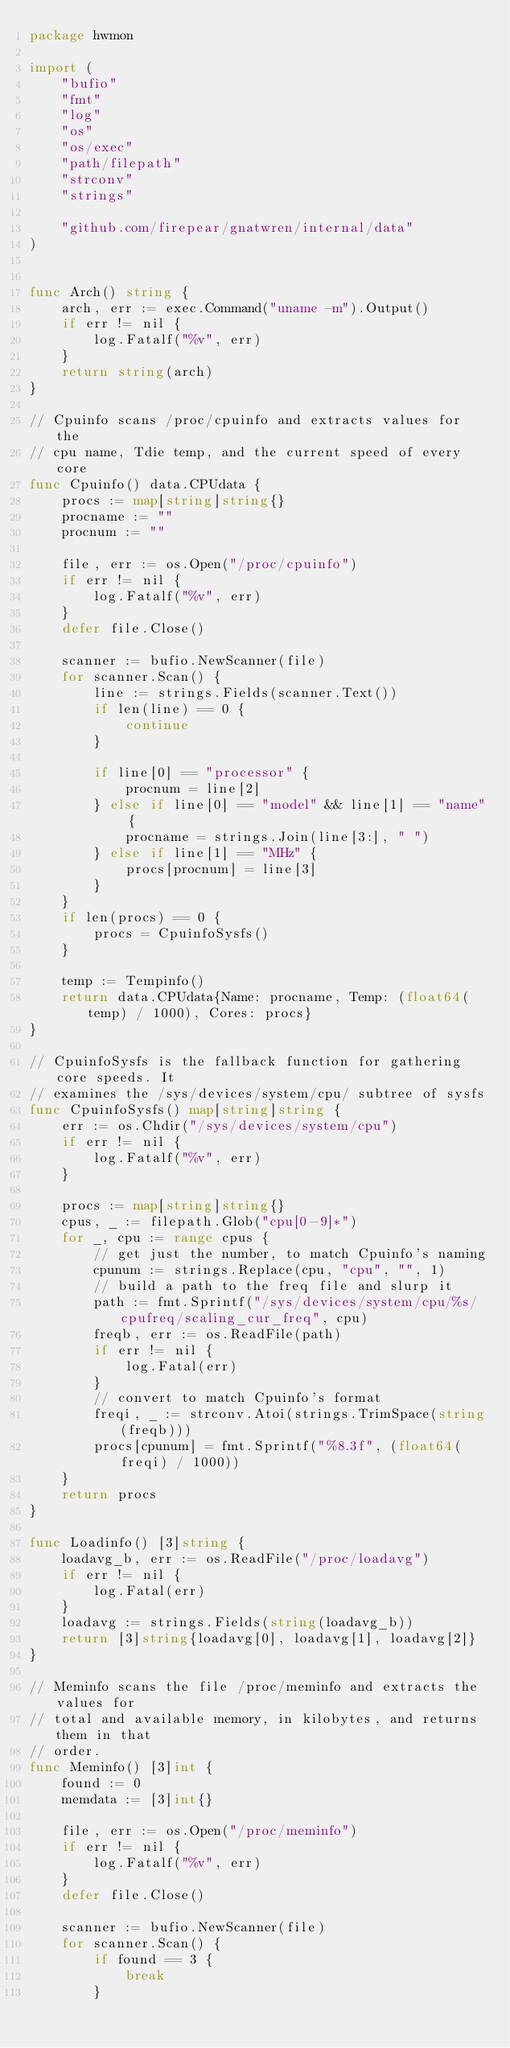Convert code to text. <code><loc_0><loc_0><loc_500><loc_500><_Go_>package hwmon

import (
	"bufio"
	"fmt"
	"log"
	"os"
	"os/exec"
	"path/filepath"
	"strconv"
	"strings"

	"github.com/firepear/gnatwren/internal/data"
)


func Arch() string {
	arch, err := exec.Command("uname -m").Output()
	if err != nil {
		log.Fatalf("%v", err)
	}
	return string(arch)
}

// Cpuinfo scans /proc/cpuinfo and extracts values for the
// cpu name, Tdie temp, and the current speed of every core
func Cpuinfo() data.CPUdata {
	procs := map[string]string{}
	procname := ""
	procnum := ""

	file, err := os.Open("/proc/cpuinfo")
	if err != nil {
		log.Fatalf("%v", err)
	}
	defer file.Close()

	scanner := bufio.NewScanner(file)
	for scanner.Scan() {
		line := strings.Fields(scanner.Text())
		if len(line) == 0 {
			continue
		}

		if line[0] == "processor" {
			procnum = line[2]
		} else if line[0] == "model" && line[1] == "name" {
			procname = strings.Join(line[3:], " ")
		} else if line[1] == "MHz" {
			procs[procnum] = line[3]
		}
	}
	if len(procs) == 0 {
		procs = CpuinfoSysfs()
	}

	temp := Tempinfo()
	return data.CPUdata{Name: procname, Temp: (float64(temp) / 1000), Cores: procs}
}

// CpuinfoSysfs is the fallback function for gathering core speeds. It
// examines the /sys/devices/system/cpu/ subtree of sysfs
func CpuinfoSysfs() map[string]string {
	err := os.Chdir("/sys/devices/system/cpu")
	if err != nil {
		log.Fatalf("%v", err)
	}

	procs := map[string]string{}
	cpus, _ := filepath.Glob("cpu[0-9]*")
	for _, cpu := range cpus {
		// get just the number, to match Cpuinfo's naming
		cpunum := strings.Replace(cpu, "cpu", "", 1)
		// build a path to the freq file and slurp it
		path := fmt.Sprintf("/sys/devices/system/cpu/%s/cpufreq/scaling_cur_freq", cpu)
		freqb, err := os.ReadFile(path)
		if err != nil {
			log.Fatal(err)
		}
		// convert to match Cpuinfo's format
		freqi, _ := strconv.Atoi(strings.TrimSpace(string(freqb)))
		procs[cpunum] = fmt.Sprintf("%8.3f", (float64(freqi) / 1000))
	}
	return procs
}

func Loadinfo() [3]string {
	loadavg_b, err := os.ReadFile("/proc/loadavg")
	if err != nil {
		log.Fatal(err)
	}
	loadavg := strings.Fields(string(loadavg_b))
	return [3]string{loadavg[0], loadavg[1], loadavg[2]}
}

// Meminfo scans the file /proc/meminfo and extracts the values for
// total and available memory, in kilobytes, and returns them in that
// order.
func Meminfo() [3]int {
	found := 0
	memdata := [3]int{}

	file, err := os.Open("/proc/meminfo")
	if err != nil {
		log.Fatalf("%v", err)
	}
	defer file.Close()

	scanner := bufio.NewScanner(file)
	for scanner.Scan() {
		if found == 3 {
			break
		}
</code> 